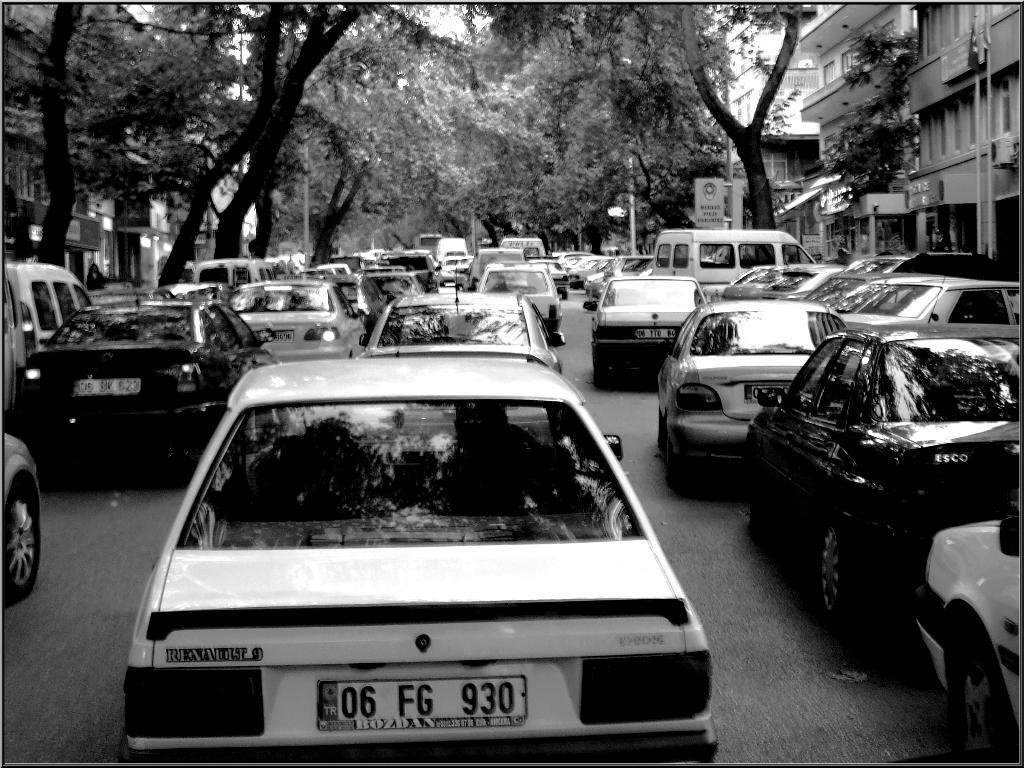In one or two sentences, can you explain what this image depicts? In this picture there are many cars in the image and there are buildings, trees, and posters in the background area of the image. 